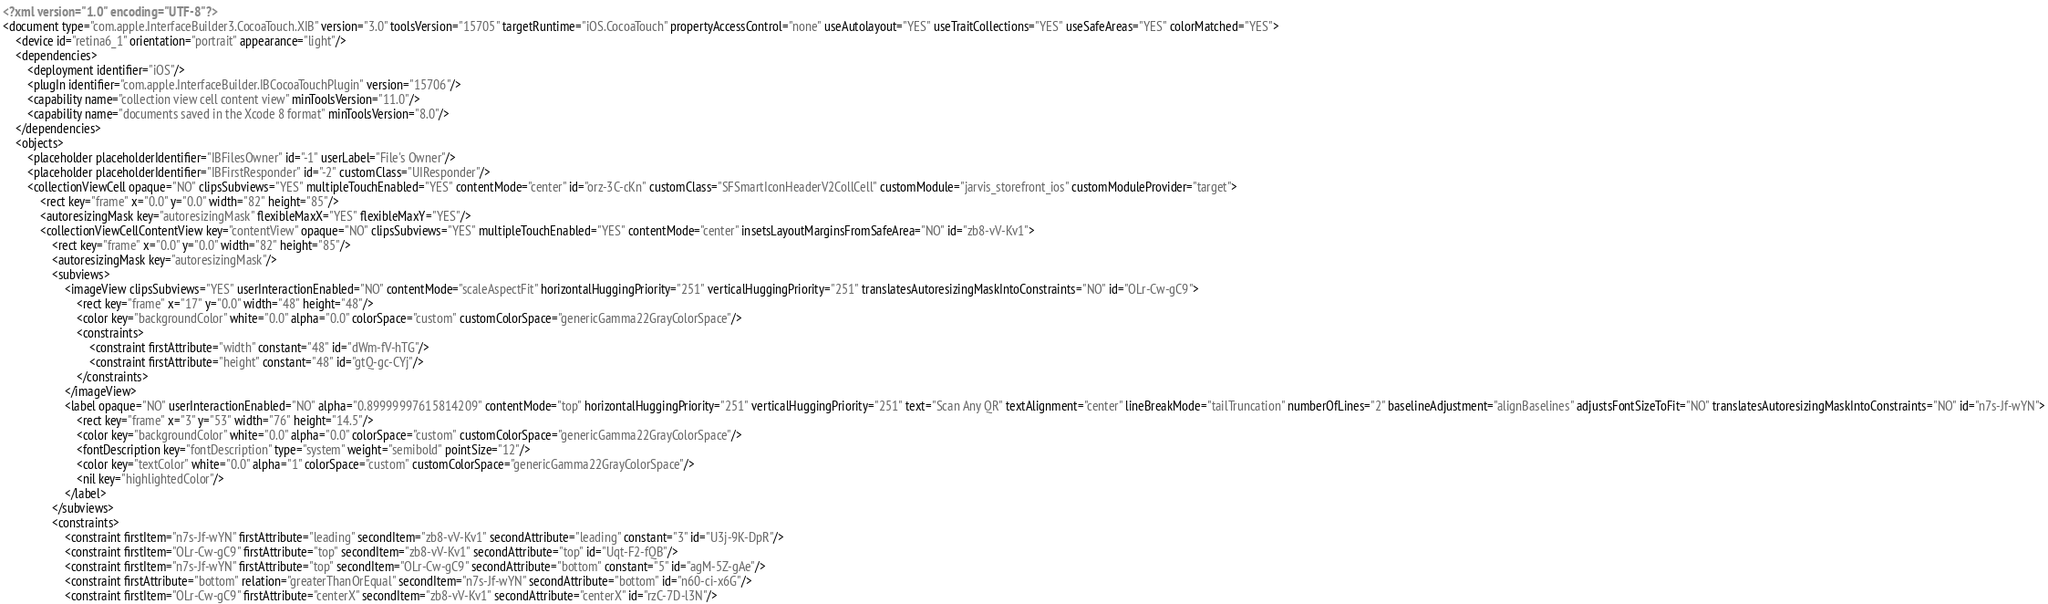Convert code to text. <code><loc_0><loc_0><loc_500><loc_500><_XML_><?xml version="1.0" encoding="UTF-8"?>
<document type="com.apple.InterfaceBuilder3.CocoaTouch.XIB" version="3.0" toolsVersion="15705" targetRuntime="iOS.CocoaTouch" propertyAccessControl="none" useAutolayout="YES" useTraitCollections="YES" useSafeAreas="YES" colorMatched="YES">
    <device id="retina6_1" orientation="portrait" appearance="light"/>
    <dependencies>
        <deployment identifier="iOS"/>
        <plugIn identifier="com.apple.InterfaceBuilder.IBCocoaTouchPlugin" version="15706"/>
        <capability name="collection view cell content view" minToolsVersion="11.0"/>
        <capability name="documents saved in the Xcode 8 format" minToolsVersion="8.0"/>
    </dependencies>
    <objects>
        <placeholder placeholderIdentifier="IBFilesOwner" id="-1" userLabel="File's Owner"/>
        <placeholder placeholderIdentifier="IBFirstResponder" id="-2" customClass="UIResponder"/>
        <collectionViewCell opaque="NO" clipsSubviews="YES" multipleTouchEnabled="YES" contentMode="center" id="orz-3C-cKn" customClass="SFSmartIconHeaderV2CollCell" customModule="jarvis_storefront_ios" customModuleProvider="target">
            <rect key="frame" x="0.0" y="0.0" width="82" height="85"/>
            <autoresizingMask key="autoresizingMask" flexibleMaxX="YES" flexibleMaxY="YES"/>
            <collectionViewCellContentView key="contentView" opaque="NO" clipsSubviews="YES" multipleTouchEnabled="YES" contentMode="center" insetsLayoutMarginsFromSafeArea="NO" id="zb8-vV-Kv1">
                <rect key="frame" x="0.0" y="0.0" width="82" height="85"/>
                <autoresizingMask key="autoresizingMask"/>
                <subviews>
                    <imageView clipsSubviews="YES" userInteractionEnabled="NO" contentMode="scaleAspectFit" horizontalHuggingPriority="251" verticalHuggingPriority="251" translatesAutoresizingMaskIntoConstraints="NO" id="OLr-Cw-gC9">
                        <rect key="frame" x="17" y="0.0" width="48" height="48"/>
                        <color key="backgroundColor" white="0.0" alpha="0.0" colorSpace="custom" customColorSpace="genericGamma22GrayColorSpace"/>
                        <constraints>
                            <constraint firstAttribute="width" constant="48" id="dWm-fV-hTG"/>
                            <constraint firstAttribute="height" constant="48" id="gtQ-gc-CYj"/>
                        </constraints>
                    </imageView>
                    <label opaque="NO" userInteractionEnabled="NO" alpha="0.89999997615814209" contentMode="top" horizontalHuggingPriority="251" verticalHuggingPriority="251" text="Scan Any QR" textAlignment="center" lineBreakMode="tailTruncation" numberOfLines="2" baselineAdjustment="alignBaselines" adjustsFontSizeToFit="NO" translatesAutoresizingMaskIntoConstraints="NO" id="n7s-Jf-wYN">
                        <rect key="frame" x="3" y="53" width="76" height="14.5"/>
                        <color key="backgroundColor" white="0.0" alpha="0.0" colorSpace="custom" customColorSpace="genericGamma22GrayColorSpace"/>
                        <fontDescription key="fontDescription" type="system" weight="semibold" pointSize="12"/>
                        <color key="textColor" white="0.0" alpha="1" colorSpace="custom" customColorSpace="genericGamma22GrayColorSpace"/>
                        <nil key="highlightedColor"/>
                    </label>
                </subviews>
                <constraints>
                    <constraint firstItem="n7s-Jf-wYN" firstAttribute="leading" secondItem="zb8-vV-Kv1" secondAttribute="leading" constant="3" id="U3j-9K-DpR"/>
                    <constraint firstItem="OLr-Cw-gC9" firstAttribute="top" secondItem="zb8-vV-Kv1" secondAttribute="top" id="Uqt-F2-fQB"/>
                    <constraint firstItem="n7s-Jf-wYN" firstAttribute="top" secondItem="OLr-Cw-gC9" secondAttribute="bottom" constant="5" id="agM-5Z-gAe"/>
                    <constraint firstAttribute="bottom" relation="greaterThanOrEqual" secondItem="n7s-Jf-wYN" secondAttribute="bottom" id="n60-ci-x6G"/>
                    <constraint firstItem="OLr-Cw-gC9" firstAttribute="centerX" secondItem="zb8-vV-Kv1" secondAttribute="centerX" id="rzC-7D-l3N"/></code> 